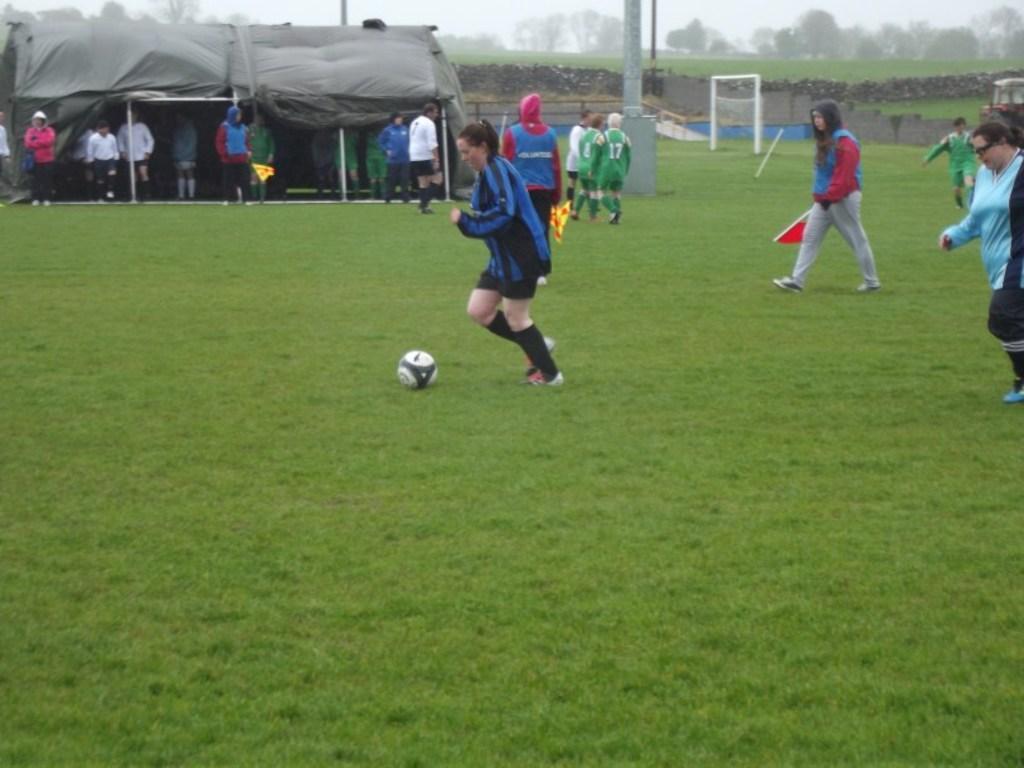Please provide a concise description of this image. In this image I can see an open grass ground and on it I can see few people are standing. I can also see few of them are holding flags and here I can see a football. In the background I can see a black color tent, number of trees and a goal post. 